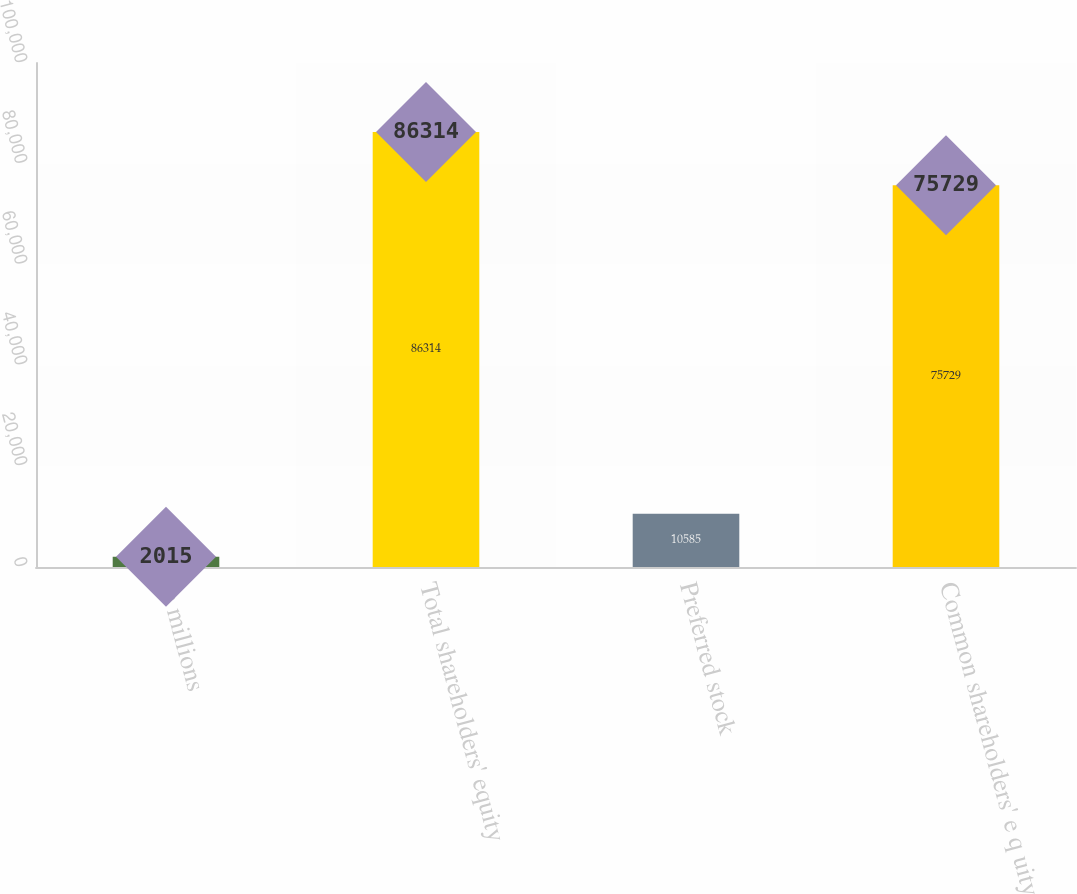Convert chart to OTSL. <chart><loc_0><loc_0><loc_500><loc_500><bar_chart><fcel>in millions<fcel>Total shareholders' equity<fcel>Preferred stock<fcel>Common shareholders' e q uity<nl><fcel>2015<fcel>86314<fcel>10585<fcel>75729<nl></chart> 